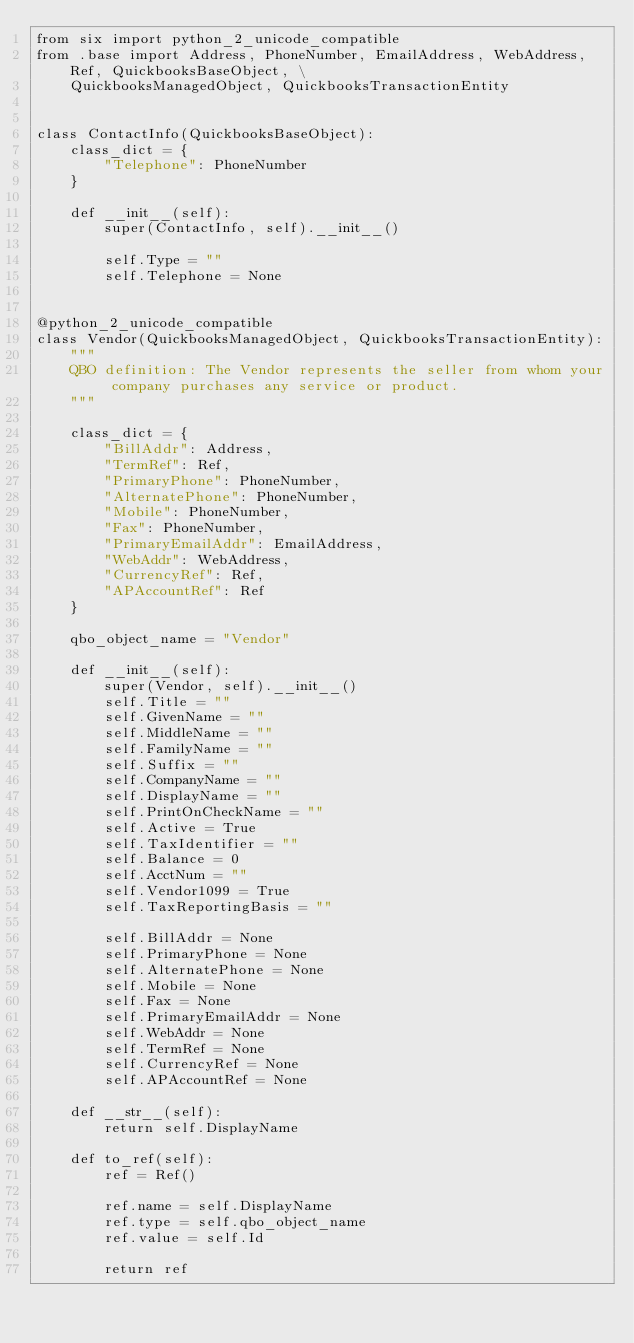Convert code to text. <code><loc_0><loc_0><loc_500><loc_500><_Python_>from six import python_2_unicode_compatible
from .base import Address, PhoneNumber, EmailAddress, WebAddress, Ref, QuickbooksBaseObject, \
    QuickbooksManagedObject, QuickbooksTransactionEntity


class ContactInfo(QuickbooksBaseObject):
    class_dict = {
        "Telephone": PhoneNumber
    }

    def __init__(self):
        super(ContactInfo, self).__init__()

        self.Type = ""
        self.Telephone = None


@python_2_unicode_compatible
class Vendor(QuickbooksManagedObject, QuickbooksTransactionEntity):
    """
    QBO definition: The Vendor represents the seller from whom your company purchases any service or product.
    """

    class_dict = {
        "BillAddr": Address,
        "TermRef": Ref,
        "PrimaryPhone": PhoneNumber,
        "AlternatePhone": PhoneNumber,
        "Mobile": PhoneNumber,
        "Fax": PhoneNumber,
        "PrimaryEmailAddr": EmailAddress,
        "WebAddr": WebAddress,
        "CurrencyRef": Ref,
        "APAccountRef": Ref
    }

    qbo_object_name = "Vendor"

    def __init__(self):
        super(Vendor, self).__init__()
        self.Title = ""
        self.GivenName = ""
        self.MiddleName = ""
        self.FamilyName = ""
        self.Suffix = ""
        self.CompanyName = ""
        self.DisplayName = ""
        self.PrintOnCheckName = ""
        self.Active = True
        self.TaxIdentifier = ""
        self.Balance = 0
        self.AcctNum = ""
        self.Vendor1099 = True
        self.TaxReportingBasis = ""

        self.BillAddr = None
        self.PrimaryPhone = None
        self.AlternatePhone = None
        self.Mobile = None
        self.Fax = None
        self.PrimaryEmailAddr = None
        self.WebAddr = None
        self.TermRef = None
        self.CurrencyRef = None
        self.APAccountRef = None

    def __str__(self):
        return self.DisplayName

    def to_ref(self):
        ref = Ref()

        ref.name = self.DisplayName
        ref.type = self.qbo_object_name
        ref.value = self.Id

        return ref
</code> 